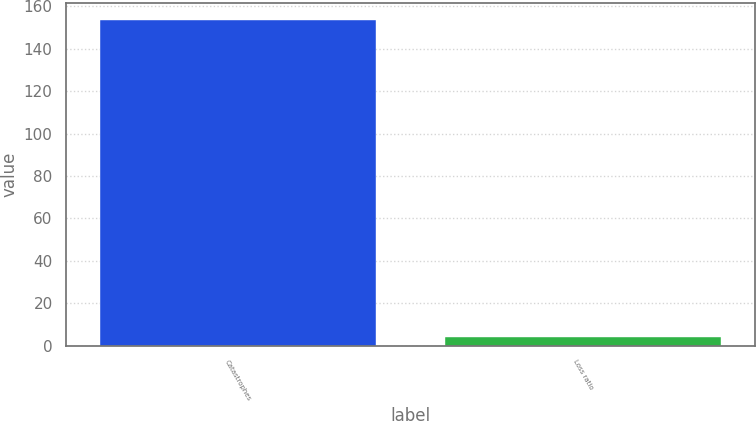Convert chart to OTSL. <chart><loc_0><loc_0><loc_500><loc_500><bar_chart><fcel>Catastrophes<fcel>Loss ratio<nl><fcel>153.8<fcel>4.2<nl></chart> 